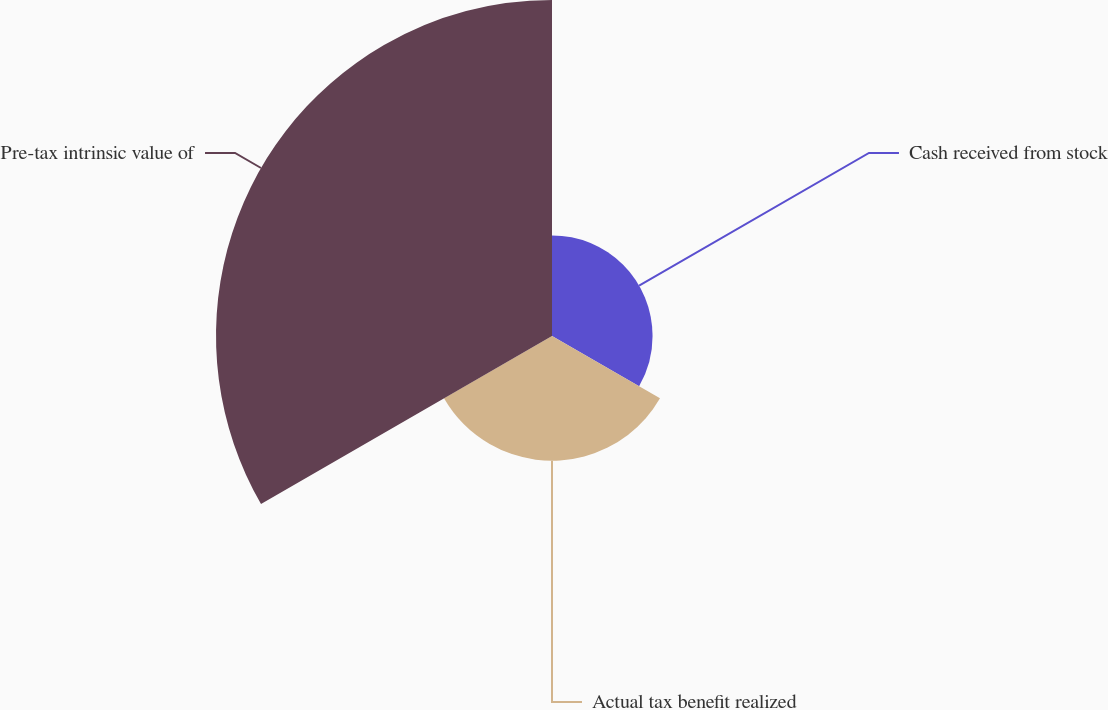Convert chart to OTSL. <chart><loc_0><loc_0><loc_500><loc_500><pie_chart><fcel>Cash received from stock<fcel>Actual tax benefit realized<fcel>Pre-tax intrinsic value of<nl><fcel>17.92%<fcel>22.22%<fcel>59.86%<nl></chart> 